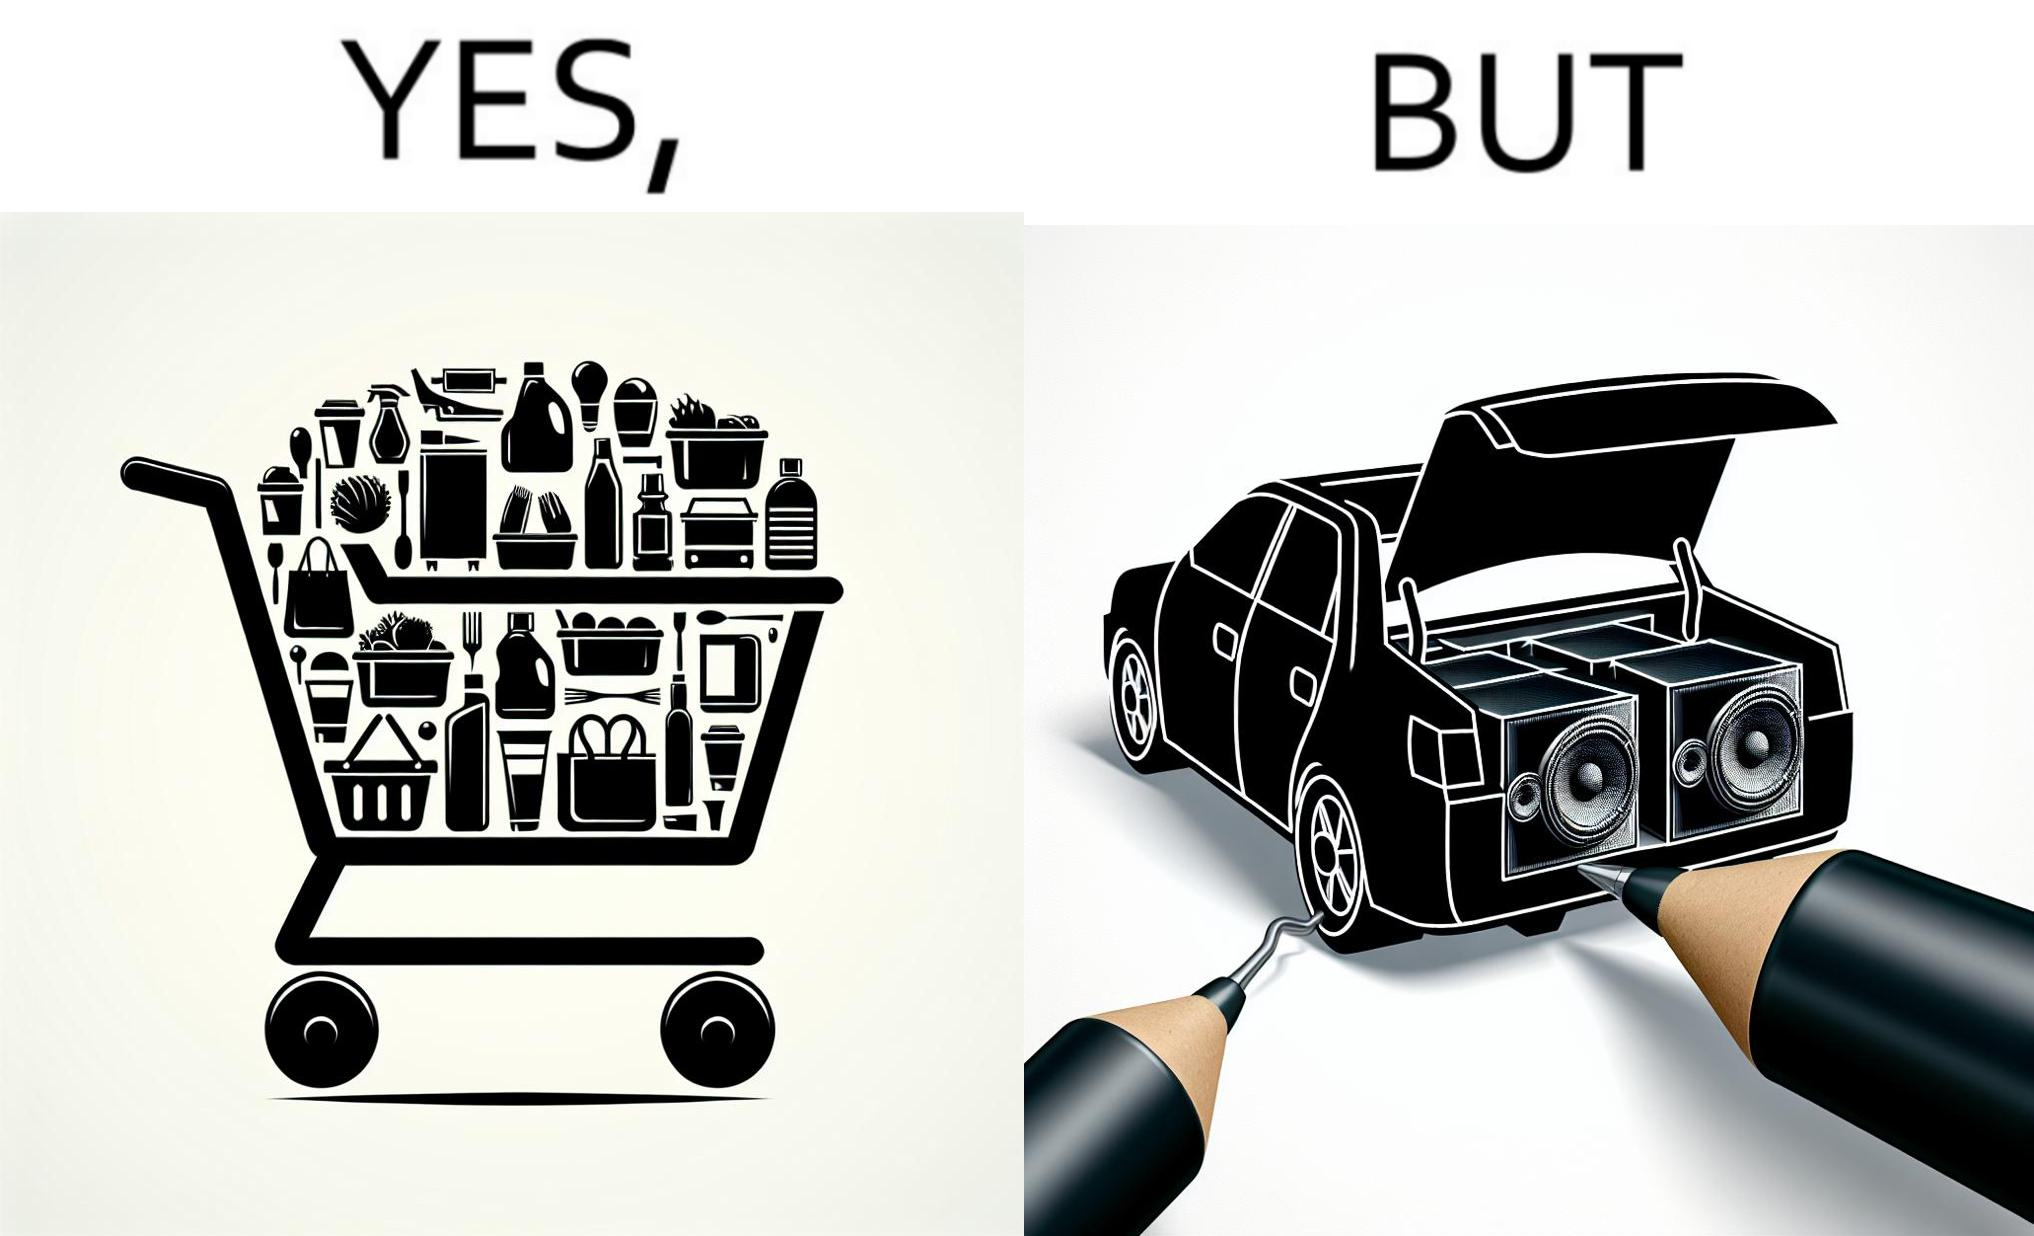Is this image satirical or non-satirical? Yes, this image is satirical. 